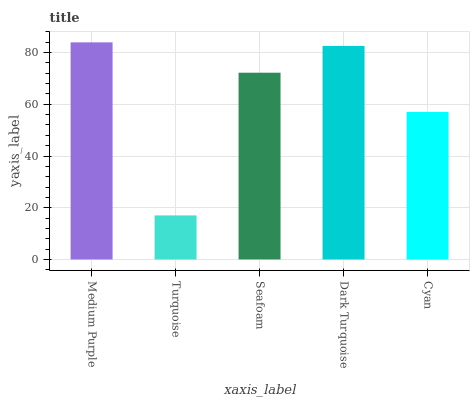Is Turquoise the minimum?
Answer yes or no. Yes. Is Medium Purple the maximum?
Answer yes or no. Yes. Is Seafoam the minimum?
Answer yes or no. No. Is Seafoam the maximum?
Answer yes or no. No. Is Seafoam greater than Turquoise?
Answer yes or no. Yes. Is Turquoise less than Seafoam?
Answer yes or no. Yes. Is Turquoise greater than Seafoam?
Answer yes or no. No. Is Seafoam less than Turquoise?
Answer yes or no. No. Is Seafoam the high median?
Answer yes or no. Yes. Is Seafoam the low median?
Answer yes or no. Yes. Is Medium Purple the high median?
Answer yes or no. No. Is Dark Turquoise the low median?
Answer yes or no. No. 